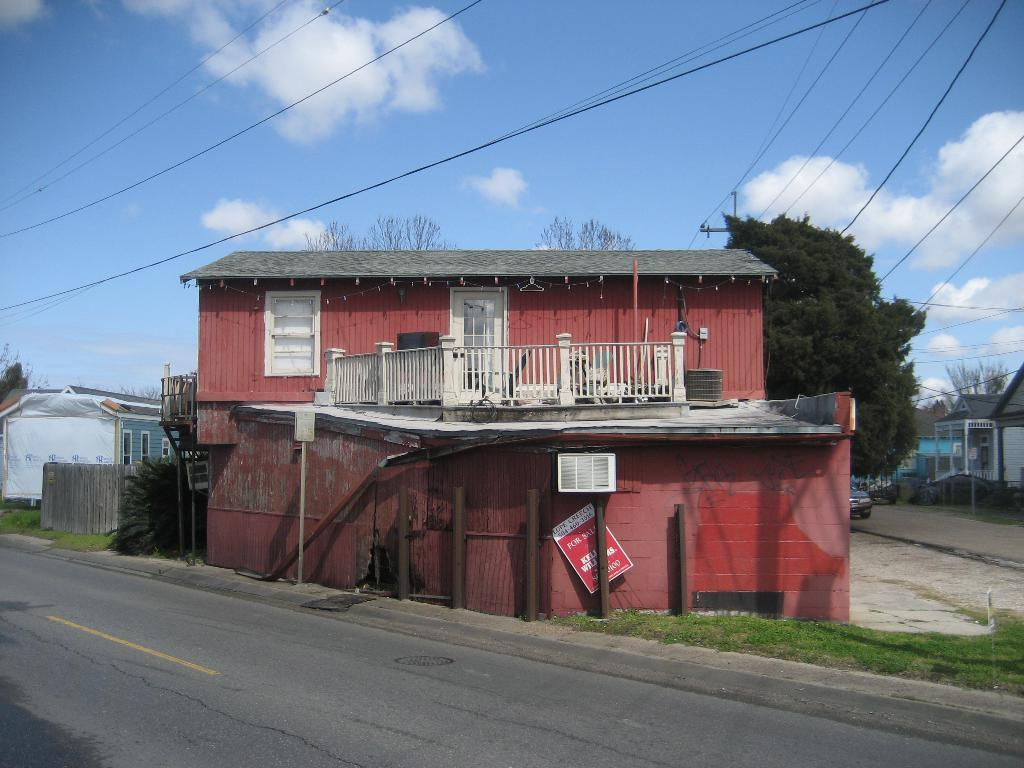What type of structure is visible in the image? There is a building in the image. Are there any other structures nearby? Yes, there are houses around the building. What type of natural elements can be seen in the image? There are trees in the image. Can you describe the road in the image? There is a vehicle parked on the right side of the road in the image. What type of ship can be seen sailing in the image? There is no ship present in the image; it features a building, houses, trees, and a parked vehicle. 